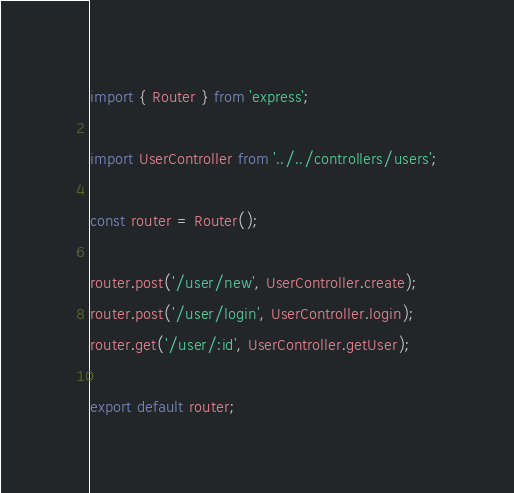<code> <loc_0><loc_0><loc_500><loc_500><_JavaScript_>import { Router } from 'express';

import UserController from '../../controllers/users';

const router = Router();

router.post('/user/new', UserController.create);
router.post('/user/login', UserController.login);
router.get('/user/:id', UserController.getUser);

export default router;
</code> 